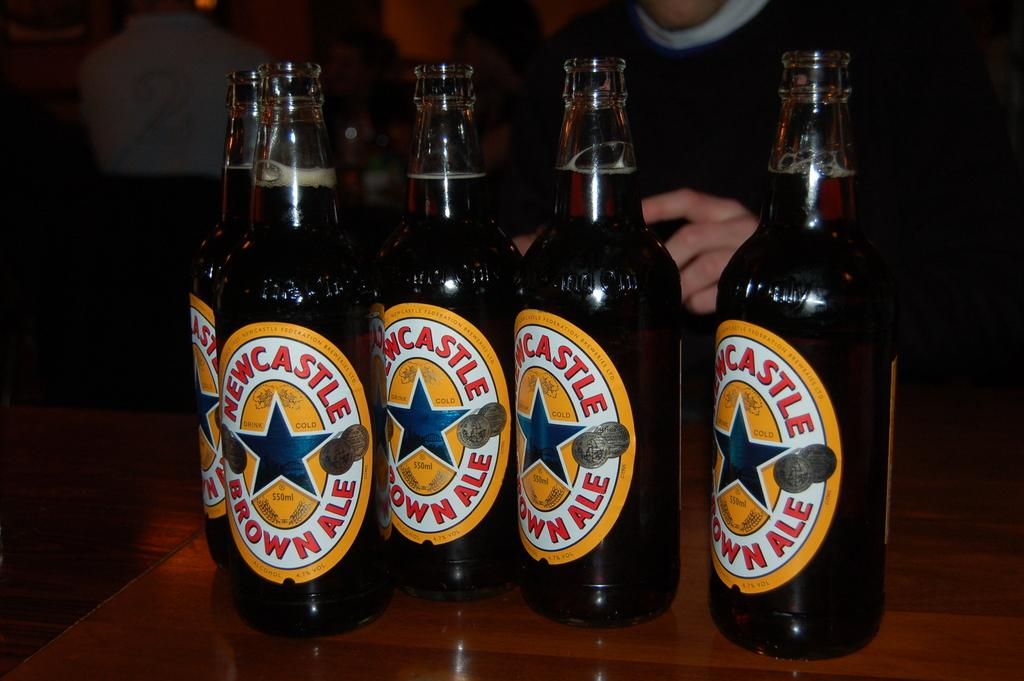How many bottles with stickers are in the image? There are four bottles with stickers in the image. What is inside the bottles? The bottles contain drinks. Where are the bottles located? The bottles are placed on a table. What can be observed about the background of the image? The background of the image is dark. What type of clam is sitting on the table next to the bottles? There is no clam present in the image; it only features four bottles with stickers placed on a table. 